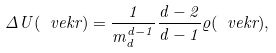Convert formula to latex. <formula><loc_0><loc_0><loc_500><loc_500>\Delta U ( \ v e k { r } ) = \frac { 1 } { m _ { d } ^ { d - 1 } } \frac { d - 2 } { d - 1 } \varrho ( \ v e k { r } ) ,</formula> 